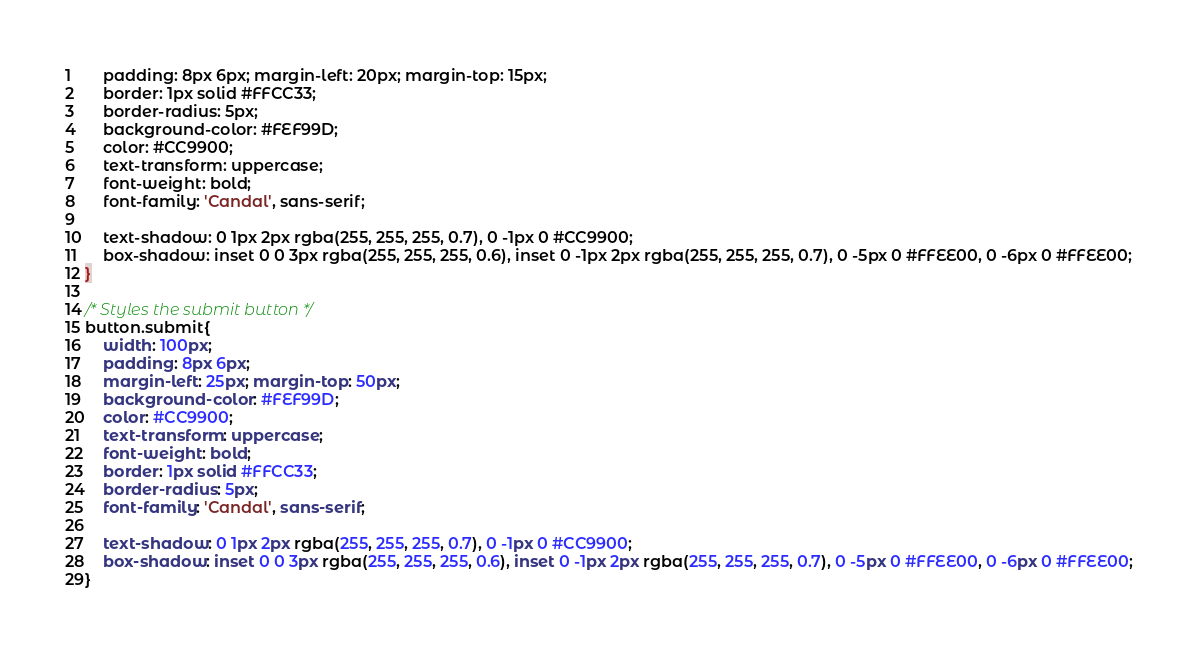Convert code to text. <code><loc_0><loc_0><loc_500><loc_500><_CSS_>    padding: 8px 6px; margin-left: 20px; margin-top: 15px;
    border: 1px solid #FFCC33;
    border-radius: 5px; 
    background-color: #FEF99D; 
    color: #CC9900;
    text-transform: uppercase; 
    font-weight: bold; 
    font-family: 'Candal', sans-serif;

    text-shadow: 0 1px 2px rgba(255, 255, 255, 0.7), 0 -1px 0 #CC9900;  
    box-shadow: inset 0 0 3px rgba(255, 255, 255, 0.6), inset 0 -1px 2px rgba(255, 255, 255, 0.7), 0 -5px 0 #FFEE00, 0 -6px 0 #FFEE00;
}

/* Styles the submit button */
button.submit{ 
    width: 100px; 
    padding: 8px 6px; 
    margin-left: 25px; margin-top: 50px;
    background-color: #FEF99D; 
    color: #CC9900;
    text-transform: uppercase; 
    font-weight: bold; 
    border: 1px solid #FFCC33; 
    border-radius: 5px; 
    font-family: 'Candal', sans-serif;
    
    text-shadow: 0 1px 2px rgba(255, 255, 255, 0.7), 0 -1px 0 #CC9900;  
    box-shadow: inset 0 0 3px rgba(255, 255, 255, 0.6), inset 0 -1px 2px rgba(255, 255, 255, 0.7), 0 -5px 0 #FFEE00, 0 -6px 0 #FFEE00;
}
</code> 